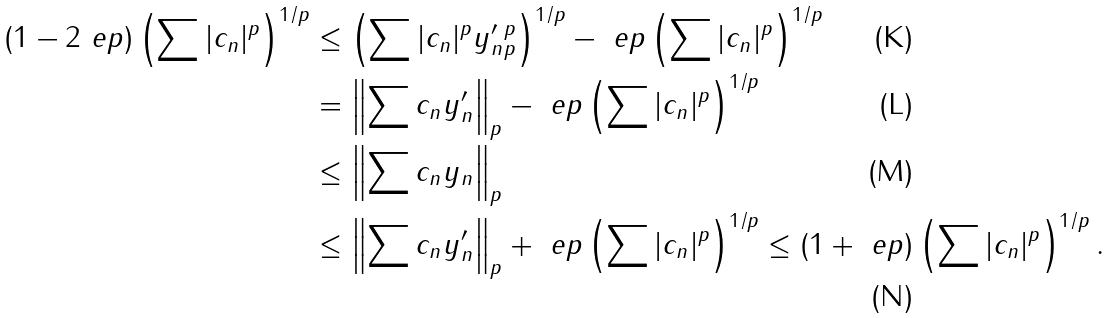<formula> <loc_0><loc_0><loc_500><loc_500>( 1 - 2 \ e p ) \left ( \sum | c _ { n } | ^ { p } \right ) ^ { 1 / p } & \leq \left ( \sum | c _ { n } | ^ { p } \| y ^ { \prime } _ { n } \| _ { p } ^ { p } \right ) ^ { 1 / p } - \ e p \left ( \sum | c _ { n } | ^ { p } \right ) ^ { 1 / p } \\ & = \left \| \sum c _ { n } y ^ { \prime } _ { n } \right \| _ { p } - \ e p \left ( \sum | c _ { n } | ^ { p } \right ) ^ { 1 / p } \\ & \leq \left \| \sum c _ { n } y _ { n } \right \| _ { p } \\ & \leq \left \| \sum c _ { n } y ^ { \prime } _ { n } \right \| _ { p } + \ e p \left ( \sum | c _ { n } | ^ { p } \right ) ^ { 1 / p } \leq ( 1 + \ e p ) \left ( \sum | c _ { n } | ^ { p } \right ) ^ { 1 / p } .</formula> 